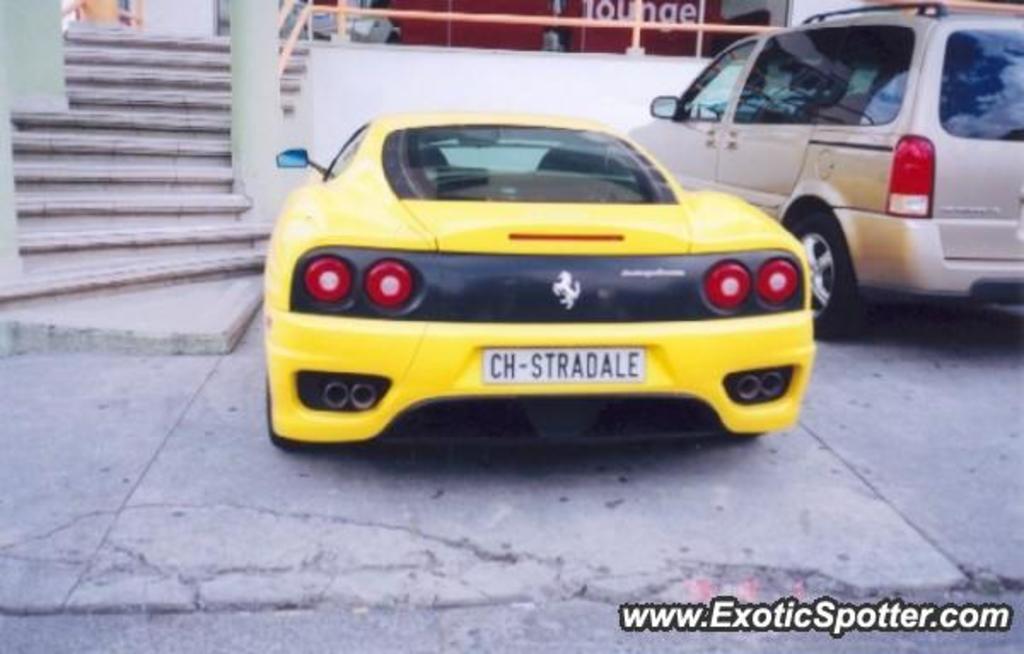In one or two sentences, can you explain what this image depicts? As we can see in the image there are stairs, wall, banner and two cars. The car on the right side is in white color and the car in the middle is in yellow color. 